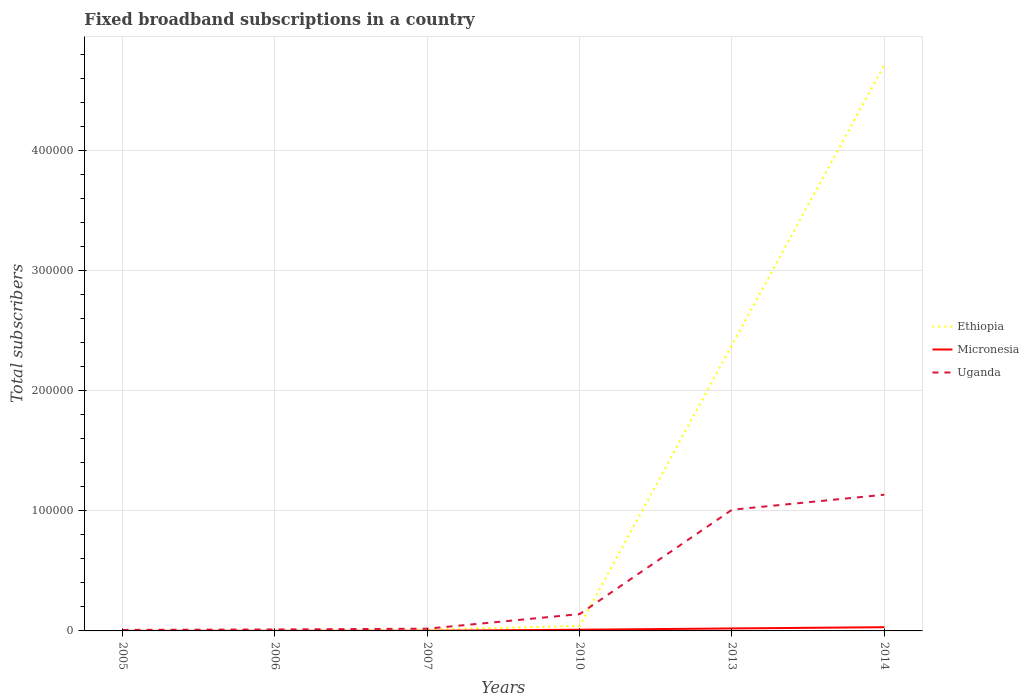Does the line corresponding to Micronesia intersect with the line corresponding to Uganda?
Provide a short and direct response. No. Across all years, what is the maximum number of broadband subscriptions in Uganda?
Your answer should be very brief. 850. What is the total number of broadband subscriptions in Micronesia in the graph?
Your response must be concise. -903. What is the difference between the highest and the second highest number of broadband subscriptions in Ethiopia?
Keep it short and to the point. 4.71e+05. Is the number of broadband subscriptions in Uganda strictly greater than the number of broadband subscriptions in Ethiopia over the years?
Make the answer very short. No. How many lines are there?
Offer a very short reply. 3. How many years are there in the graph?
Keep it short and to the point. 6. What is the difference between two consecutive major ticks on the Y-axis?
Give a very brief answer. 1.00e+05. Does the graph contain any zero values?
Give a very brief answer. No. Does the graph contain grids?
Give a very brief answer. Yes. How many legend labels are there?
Offer a very short reply. 3. How are the legend labels stacked?
Keep it short and to the point. Vertical. What is the title of the graph?
Offer a terse response. Fixed broadband subscriptions in a country. Does "Vietnam" appear as one of the legend labels in the graph?
Keep it short and to the point. No. What is the label or title of the X-axis?
Make the answer very short. Years. What is the label or title of the Y-axis?
Give a very brief answer. Total subscribers. What is the Total subscribers in Uganda in 2005?
Offer a terse response. 850. What is the Total subscribers of Ethiopia in 2006?
Ensure brevity in your answer.  261. What is the Total subscribers in Micronesia in 2006?
Offer a very short reply. 95. What is the Total subscribers of Uganda in 2006?
Your response must be concise. 1210. What is the Total subscribers in Ethiopia in 2007?
Your answer should be compact. 1036. What is the Total subscribers of Micronesia in 2007?
Provide a short and direct response. 116. What is the Total subscribers of Uganda in 2007?
Ensure brevity in your answer.  1860. What is the Total subscribers in Ethiopia in 2010?
Your answer should be compact. 4107. What is the Total subscribers of Micronesia in 2010?
Make the answer very short. 998. What is the Total subscribers in Uganda in 2010?
Give a very brief answer. 1.40e+04. What is the Total subscribers of Ethiopia in 2013?
Provide a short and direct response. 2.38e+05. What is the Total subscribers in Micronesia in 2013?
Your response must be concise. 2063. What is the Total subscribers in Uganda in 2013?
Offer a terse response. 1.01e+05. What is the Total subscribers of Ethiopia in 2014?
Keep it short and to the point. 4.71e+05. What is the Total subscribers of Micronesia in 2014?
Your response must be concise. 3092. What is the Total subscribers of Uganda in 2014?
Keep it short and to the point. 1.13e+05. Across all years, what is the maximum Total subscribers of Ethiopia?
Offer a very short reply. 4.71e+05. Across all years, what is the maximum Total subscribers in Micronesia?
Make the answer very short. 3092. Across all years, what is the maximum Total subscribers in Uganda?
Offer a terse response. 1.13e+05. Across all years, what is the minimum Total subscribers of Ethiopia?
Provide a short and direct response. 61. Across all years, what is the minimum Total subscribers of Uganda?
Offer a terse response. 850. What is the total Total subscribers in Ethiopia in the graph?
Ensure brevity in your answer.  7.15e+05. What is the total Total subscribers of Micronesia in the graph?
Offer a terse response. 6410. What is the total Total subscribers of Uganda in the graph?
Keep it short and to the point. 2.32e+05. What is the difference between the Total subscribers in Ethiopia in 2005 and that in 2006?
Provide a succinct answer. -200. What is the difference between the Total subscribers in Micronesia in 2005 and that in 2006?
Keep it short and to the point. -49. What is the difference between the Total subscribers of Uganda in 2005 and that in 2006?
Ensure brevity in your answer.  -360. What is the difference between the Total subscribers in Ethiopia in 2005 and that in 2007?
Your answer should be compact. -975. What is the difference between the Total subscribers of Micronesia in 2005 and that in 2007?
Offer a terse response. -70. What is the difference between the Total subscribers in Uganda in 2005 and that in 2007?
Provide a succinct answer. -1010. What is the difference between the Total subscribers of Ethiopia in 2005 and that in 2010?
Make the answer very short. -4046. What is the difference between the Total subscribers in Micronesia in 2005 and that in 2010?
Your answer should be very brief. -952. What is the difference between the Total subscribers in Uganda in 2005 and that in 2010?
Give a very brief answer. -1.32e+04. What is the difference between the Total subscribers of Ethiopia in 2005 and that in 2013?
Give a very brief answer. -2.38e+05. What is the difference between the Total subscribers in Micronesia in 2005 and that in 2013?
Ensure brevity in your answer.  -2017. What is the difference between the Total subscribers in Uganda in 2005 and that in 2013?
Your answer should be very brief. -1.00e+05. What is the difference between the Total subscribers of Ethiopia in 2005 and that in 2014?
Provide a succinct answer. -4.71e+05. What is the difference between the Total subscribers of Micronesia in 2005 and that in 2014?
Provide a short and direct response. -3046. What is the difference between the Total subscribers in Uganda in 2005 and that in 2014?
Keep it short and to the point. -1.13e+05. What is the difference between the Total subscribers of Ethiopia in 2006 and that in 2007?
Keep it short and to the point. -775. What is the difference between the Total subscribers of Micronesia in 2006 and that in 2007?
Provide a short and direct response. -21. What is the difference between the Total subscribers of Uganda in 2006 and that in 2007?
Keep it short and to the point. -650. What is the difference between the Total subscribers in Ethiopia in 2006 and that in 2010?
Give a very brief answer. -3846. What is the difference between the Total subscribers of Micronesia in 2006 and that in 2010?
Keep it short and to the point. -903. What is the difference between the Total subscribers of Uganda in 2006 and that in 2010?
Provide a succinct answer. -1.28e+04. What is the difference between the Total subscribers in Ethiopia in 2006 and that in 2013?
Provide a succinct answer. -2.38e+05. What is the difference between the Total subscribers of Micronesia in 2006 and that in 2013?
Make the answer very short. -1968. What is the difference between the Total subscribers of Uganda in 2006 and that in 2013?
Ensure brevity in your answer.  -9.97e+04. What is the difference between the Total subscribers in Ethiopia in 2006 and that in 2014?
Your answer should be compact. -4.71e+05. What is the difference between the Total subscribers of Micronesia in 2006 and that in 2014?
Your answer should be compact. -2997. What is the difference between the Total subscribers of Uganda in 2006 and that in 2014?
Offer a terse response. -1.12e+05. What is the difference between the Total subscribers in Ethiopia in 2007 and that in 2010?
Your answer should be compact. -3071. What is the difference between the Total subscribers of Micronesia in 2007 and that in 2010?
Give a very brief answer. -882. What is the difference between the Total subscribers of Uganda in 2007 and that in 2010?
Provide a succinct answer. -1.21e+04. What is the difference between the Total subscribers of Ethiopia in 2007 and that in 2013?
Ensure brevity in your answer.  -2.37e+05. What is the difference between the Total subscribers in Micronesia in 2007 and that in 2013?
Make the answer very short. -1947. What is the difference between the Total subscribers of Uganda in 2007 and that in 2013?
Offer a very short reply. -9.90e+04. What is the difference between the Total subscribers in Ethiopia in 2007 and that in 2014?
Your answer should be very brief. -4.70e+05. What is the difference between the Total subscribers in Micronesia in 2007 and that in 2014?
Give a very brief answer. -2976. What is the difference between the Total subscribers in Uganda in 2007 and that in 2014?
Your answer should be very brief. -1.12e+05. What is the difference between the Total subscribers of Ethiopia in 2010 and that in 2013?
Provide a short and direct response. -2.34e+05. What is the difference between the Total subscribers of Micronesia in 2010 and that in 2013?
Offer a very short reply. -1065. What is the difference between the Total subscribers of Uganda in 2010 and that in 2013?
Ensure brevity in your answer.  -8.69e+04. What is the difference between the Total subscribers in Ethiopia in 2010 and that in 2014?
Provide a short and direct response. -4.67e+05. What is the difference between the Total subscribers of Micronesia in 2010 and that in 2014?
Ensure brevity in your answer.  -2094. What is the difference between the Total subscribers in Uganda in 2010 and that in 2014?
Keep it short and to the point. -9.94e+04. What is the difference between the Total subscribers in Ethiopia in 2013 and that in 2014?
Keep it short and to the point. -2.33e+05. What is the difference between the Total subscribers in Micronesia in 2013 and that in 2014?
Keep it short and to the point. -1029. What is the difference between the Total subscribers of Uganda in 2013 and that in 2014?
Provide a succinct answer. -1.25e+04. What is the difference between the Total subscribers in Ethiopia in 2005 and the Total subscribers in Micronesia in 2006?
Provide a succinct answer. -34. What is the difference between the Total subscribers in Ethiopia in 2005 and the Total subscribers in Uganda in 2006?
Your answer should be compact. -1149. What is the difference between the Total subscribers of Micronesia in 2005 and the Total subscribers of Uganda in 2006?
Your response must be concise. -1164. What is the difference between the Total subscribers in Ethiopia in 2005 and the Total subscribers in Micronesia in 2007?
Your response must be concise. -55. What is the difference between the Total subscribers of Ethiopia in 2005 and the Total subscribers of Uganda in 2007?
Offer a very short reply. -1799. What is the difference between the Total subscribers in Micronesia in 2005 and the Total subscribers in Uganda in 2007?
Offer a very short reply. -1814. What is the difference between the Total subscribers in Ethiopia in 2005 and the Total subscribers in Micronesia in 2010?
Keep it short and to the point. -937. What is the difference between the Total subscribers of Ethiopia in 2005 and the Total subscribers of Uganda in 2010?
Keep it short and to the point. -1.39e+04. What is the difference between the Total subscribers of Micronesia in 2005 and the Total subscribers of Uganda in 2010?
Offer a terse response. -1.40e+04. What is the difference between the Total subscribers in Ethiopia in 2005 and the Total subscribers in Micronesia in 2013?
Keep it short and to the point. -2002. What is the difference between the Total subscribers in Ethiopia in 2005 and the Total subscribers in Uganda in 2013?
Give a very brief answer. -1.01e+05. What is the difference between the Total subscribers in Micronesia in 2005 and the Total subscribers in Uganda in 2013?
Offer a terse response. -1.01e+05. What is the difference between the Total subscribers of Ethiopia in 2005 and the Total subscribers of Micronesia in 2014?
Provide a succinct answer. -3031. What is the difference between the Total subscribers of Ethiopia in 2005 and the Total subscribers of Uganda in 2014?
Make the answer very short. -1.13e+05. What is the difference between the Total subscribers of Micronesia in 2005 and the Total subscribers of Uganda in 2014?
Your response must be concise. -1.13e+05. What is the difference between the Total subscribers of Ethiopia in 2006 and the Total subscribers of Micronesia in 2007?
Provide a succinct answer. 145. What is the difference between the Total subscribers of Ethiopia in 2006 and the Total subscribers of Uganda in 2007?
Keep it short and to the point. -1599. What is the difference between the Total subscribers in Micronesia in 2006 and the Total subscribers in Uganda in 2007?
Offer a terse response. -1765. What is the difference between the Total subscribers of Ethiopia in 2006 and the Total subscribers of Micronesia in 2010?
Offer a very short reply. -737. What is the difference between the Total subscribers of Ethiopia in 2006 and the Total subscribers of Uganda in 2010?
Your response must be concise. -1.37e+04. What is the difference between the Total subscribers in Micronesia in 2006 and the Total subscribers in Uganda in 2010?
Your response must be concise. -1.39e+04. What is the difference between the Total subscribers in Ethiopia in 2006 and the Total subscribers in Micronesia in 2013?
Ensure brevity in your answer.  -1802. What is the difference between the Total subscribers of Ethiopia in 2006 and the Total subscribers of Uganda in 2013?
Your answer should be compact. -1.01e+05. What is the difference between the Total subscribers of Micronesia in 2006 and the Total subscribers of Uganda in 2013?
Offer a terse response. -1.01e+05. What is the difference between the Total subscribers of Ethiopia in 2006 and the Total subscribers of Micronesia in 2014?
Your response must be concise. -2831. What is the difference between the Total subscribers in Ethiopia in 2006 and the Total subscribers in Uganda in 2014?
Provide a succinct answer. -1.13e+05. What is the difference between the Total subscribers in Micronesia in 2006 and the Total subscribers in Uganda in 2014?
Provide a succinct answer. -1.13e+05. What is the difference between the Total subscribers of Ethiopia in 2007 and the Total subscribers of Uganda in 2010?
Ensure brevity in your answer.  -1.30e+04. What is the difference between the Total subscribers of Micronesia in 2007 and the Total subscribers of Uganda in 2010?
Offer a very short reply. -1.39e+04. What is the difference between the Total subscribers of Ethiopia in 2007 and the Total subscribers of Micronesia in 2013?
Provide a succinct answer. -1027. What is the difference between the Total subscribers in Ethiopia in 2007 and the Total subscribers in Uganda in 2013?
Give a very brief answer. -9.99e+04. What is the difference between the Total subscribers of Micronesia in 2007 and the Total subscribers of Uganda in 2013?
Make the answer very short. -1.01e+05. What is the difference between the Total subscribers of Ethiopia in 2007 and the Total subscribers of Micronesia in 2014?
Make the answer very short. -2056. What is the difference between the Total subscribers of Ethiopia in 2007 and the Total subscribers of Uganda in 2014?
Your answer should be very brief. -1.12e+05. What is the difference between the Total subscribers of Micronesia in 2007 and the Total subscribers of Uganda in 2014?
Provide a succinct answer. -1.13e+05. What is the difference between the Total subscribers of Ethiopia in 2010 and the Total subscribers of Micronesia in 2013?
Give a very brief answer. 2044. What is the difference between the Total subscribers of Ethiopia in 2010 and the Total subscribers of Uganda in 2013?
Make the answer very short. -9.68e+04. What is the difference between the Total subscribers of Micronesia in 2010 and the Total subscribers of Uganda in 2013?
Offer a terse response. -9.99e+04. What is the difference between the Total subscribers of Ethiopia in 2010 and the Total subscribers of Micronesia in 2014?
Offer a very short reply. 1015. What is the difference between the Total subscribers in Ethiopia in 2010 and the Total subscribers in Uganda in 2014?
Provide a short and direct response. -1.09e+05. What is the difference between the Total subscribers in Micronesia in 2010 and the Total subscribers in Uganda in 2014?
Make the answer very short. -1.12e+05. What is the difference between the Total subscribers in Ethiopia in 2013 and the Total subscribers in Micronesia in 2014?
Provide a short and direct response. 2.35e+05. What is the difference between the Total subscribers in Ethiopia in 2013 and the Total subscribers in Uganda in 2014?
Make the answer very short. 1.25e+05. What is the difference between the Total subscribers of Micronesia in 2013 and the Total subscribers of Uganda in 2014?
Give a very brief answer. -1.11e+05. What is the average Total subscribers of Ethiopia per year?
Offer a very short reply. 1.19e+05. What is the average Total subscribers of Micronesia per year?
Provide a short and direct response. 1068.33. What is the average Total subscribers of Uganda per year?
Give a very brief answer. 3.87e+04. In the year 2005, what is the difference between the Total subscribers of Ethiopia and Total subscribers of Uganda?
Offer a very short reply. -789. In the year 2005, what is the difference between the Total subscribers of Micronesia and Total subscribers of Uganda?
Make the answer very short. -804. In the year 2006, what is the difference between the Total subscribers in Ethiopia and Total subscribers in Micronesia?
Your response must be concise. 166. In the year 2006, what is the difference between the Total subscribers in Ethiopia and Total subscribers in Uganda?
Provide a short and direct response. -949. In the year 2006, what is the difference between the Total subscribers of Micronesia and Total subscribers of Uganda?
Ensure brevity in your answer.  -1115. In the year 2007, what is the difference between the Total subscribers in Ethiopia and Total subscribers in Micronesia?
Provide a short and direct response. 920. In the year 2007, what is the difference between the Total subscribers in Ethiopia and Total subscribers in Uganda?
Give a very brief answer. -824. In the year 2007, what is the difference between the Total subscribers of Micronesia and Total subscribers of Uganda?
Provide a succinct answer. -1744. In the year 2010, what is the difference between the Total subscribers of Ethiopia and Total subscribers of Micronesia?
Offer a terse response. 3109. In the year 2010, what is the difference between the Total subscribers in Ethiopia and Total subscribers in Uganda?
Your answer should be compact. -9893. In the year 2010, what is the difference between the Total subscribers in Micronesia and Total subscribers in Uganda?
Your response must be concise. -1.30e+04. In the year 2013, what is the difference between the Total subscribers of Ethiopia and Total subscribers of Micronesia?
Ensure brevity in your answer.  2.36e+05. In the year 2013, what is the difference between the Total subscribers of Ethiopia and Total subscribers of Uganda?
Provide a succinct answer. 1.37e+05. In the year 2013, what is the difference between the Total subscribers of Micronesia and Total subscribers of Uganda?
Give a very brief answer. -9.88e+04. In the year 2014, what is the difference between the Total subscribers of Ethiopia and Total subscribers of Micronesia?
Provide a succinct answer. 4.68e+05. In the year 2014, what is the difference between the Total subscribers of Ethiopia and Total subscribers of Uganda?
Your answer should be very brief. 3.58e+05. In the year 2014, what is the difference between the Total subscribers of Micronesia and Total subscribers of Uganda?
Your response must be concise. -1.10e+05. What is the ratio of the Total subscribers of Ethiopia in 2005 to that in 2006?
Your answer should be very brief. 0.23. What is the ratio of the Total subscribers in Micronesia in 2005 to that in 2006?
Your answer should be very brief. 0.48. What is the ratio of the Total subscribers of Uganda in 2005 to that in 2006?
Ensure brevity in your answer.  0.7. What is the ratio of the Total subscribers of Ethiopia in 2005 to that in 2007?
Your answer should be compact. 0.06. What is the ratio of the Total subscribers in Micronesia in 2005 to that in 2007?
Your answer should be very brief. 0.4. What is the ratio of the Total subscribers of Uganda in 2005 to that in 2007?
Provide a short and direct response. 0.46. What is the ratio of the Total subscribers in Ethiopia in 2005 to that in 2010?
Provide a short and direct response. 0.01. What is the ratio of the Total subscribers in Micronesia in 2005 to that in 2010?
Ensure brevity in your answer.  0.05. What is the ratio of the Total subscribers in Uganda in 2005 to that in 2010?
Make the answer very short. 0.06. What is the ratio of the Total subscribers of Ethiopia in 2005 to that in 2013?
Keep it short and to the point. 0. What is the ratio of the Total subscribers of Micronesia in 2005 to that in 2013?
Your answer should be compact. 0.02. What is the ratio of the Total subscribers of Uganda in 2005 to that in 2013?
Provide a short and direct response. 0.01. What is the ratio of the Total subscribers in Micronesia in 2005 to that in 2014?
Your answer should be very brief. 0.01. What is the ratio of the Total subscribers in Uganda in 2005 to that in 2014?
Give a very brief answer. 0.01. What is the ratio of the Total subscribers in Ethiopia in 2006 to that in 2007?
Offer a very short reply. 0.25. What is the ratio of the Total subscribers in Micronesia in 2006 to that in 2007?
Ensure brevity in your answer.  0.82. What is the ratio of the Total subscribers in Uganda in 2006 to that in 2007?
Ensure brevity in your answer.  0.65. What is the ratio of the Total subscribers in Ethiopia in 2006 to that in 2010?
Your response must be concise. 0.06. What is the ratio of the Total subscribers of Micronesia in 2006 to that in 2010?
Offer a terse response. 0.1. What is the ratio of the Total subscribers in Uganda in 2006 to that in 2010?
Ensure brevity in your answer.  0.09. What is the ratio of the Total subscribers of Ethiopia in 2006 to that in 2013?
Provide a short and direct response. 0. What is the ratio of the Total subscribers in Micronesia in 2006 to that in 2013?
Keep it short and to the point. 0.05. What is the ratio of the Total subscribers of Uganda in 2006 to that in 2013?
Offer a terse response. 0.01. What is the ratio of the Total subscribers in Ethiopia in 2006 to that in 2014?
Provide a short and direct response. 0. What is the ratio of the Total subscribers of Micronesia in 2006 to that in 2014?
Make the answer very short. 0.03. What is the ratio of the Total subscribers of Uganda in 2006 to that in 2014?
Make the answer very short. 0.01. What is the ratio of the Total subscribers in Ethiopia in 2007 to that in 2010?
Your answer should be very brief. 0.25. What is the ratio of the Total subscribers in Micronesia in 2007 to that in 2010?
Give a very brief answer. 0.12. What is the ratio of the Total subscribers in Uganda in 2007 to that in 2010?
Offer a very short reply. 0.13. What is the ratio of the Total subscribers in Ethiopia in 2007 to that in 2013?
Make the answer very short. 0. What is the ratio of the Total subscribers in Micronesia in 2007 to that in 2013?
Ensure brevity in your answer.  0.06. What is the ratio of the Total subscribers in Uganda in 2007 to that in 2013?
Provide a short and direct response. 0.02. What is the ratio of the Total subscribers of Ethiopia in 2007 to that in 2014?
Ensure brevity in your answer.  0. What is the ratio of the Total subscribers of Micronesia in 2007 to that in 2014?
Provide a short and direct response. 0.04. What is the ratio of the Total subscribers in Uganda in 2007 to that in 2014?
Provide a succinct answer. 0.02. What is the ratio of the Total subscribers of Ethiopia in 2010 to that in 2013?
Offer a very short reply. 0.02. What is the ratio of the Total subscribers of Micronesia in 2010 to that in 2013?
Keep it short and to the point. 0.48. What is the ratio of the Total subscribers in Uganda in 2010 to that in 2013?
Your answer should be very brief. 0.14. What is the ratio of the Total subscribers in Ethiopia in 2010 to that in 2014?
Your answer should be very brief. 0.01. What is the ratio of the Total subscribers of Micronesia in 2010 to that in 2014?
Keep it short and to the point. 0.32. What is the ratio of the Total subscribers of Uganda in 2010 to that in 2014?
Make the answer very short. 0.12. What is the ratio of the Total subscribers in Ethiopia in 2013 to that in 2014?
Offer a very short reply. 0.51. What is the ratio of the Total subscribers in Micronesia in 2013 to that in 2014?
Give a very brief answer. 0.67. What is the ratio of the Total subscribers in Uganda in 2013 to that in 2014?
Offer a terse response. 0.89. What is the difference between the highest and the second highest Total subscribers of Ethiopia?
Give a very brief answer. 2.33e+05. What is the difference between the highest and the second highest Total subscribers in Micronesia?
Ensure brevity in your answer.  1029. What is the difference between the highest and the second highest Total subscribers of Uganda?
Give a very brief answer. 1.25e+04. What is the difference between the highest and the lowest Total subscribers in Ethiopia?
Your response must be concise. 4.71e+05. What is the difference between the highest and the lowest Total subscribers of Micronesia?
Your answer should be compact. 3046. What is the difference between the highest and the lowest Total subscribers of Uganda?
Ensure brevity in your answer.  1.13e+05. 